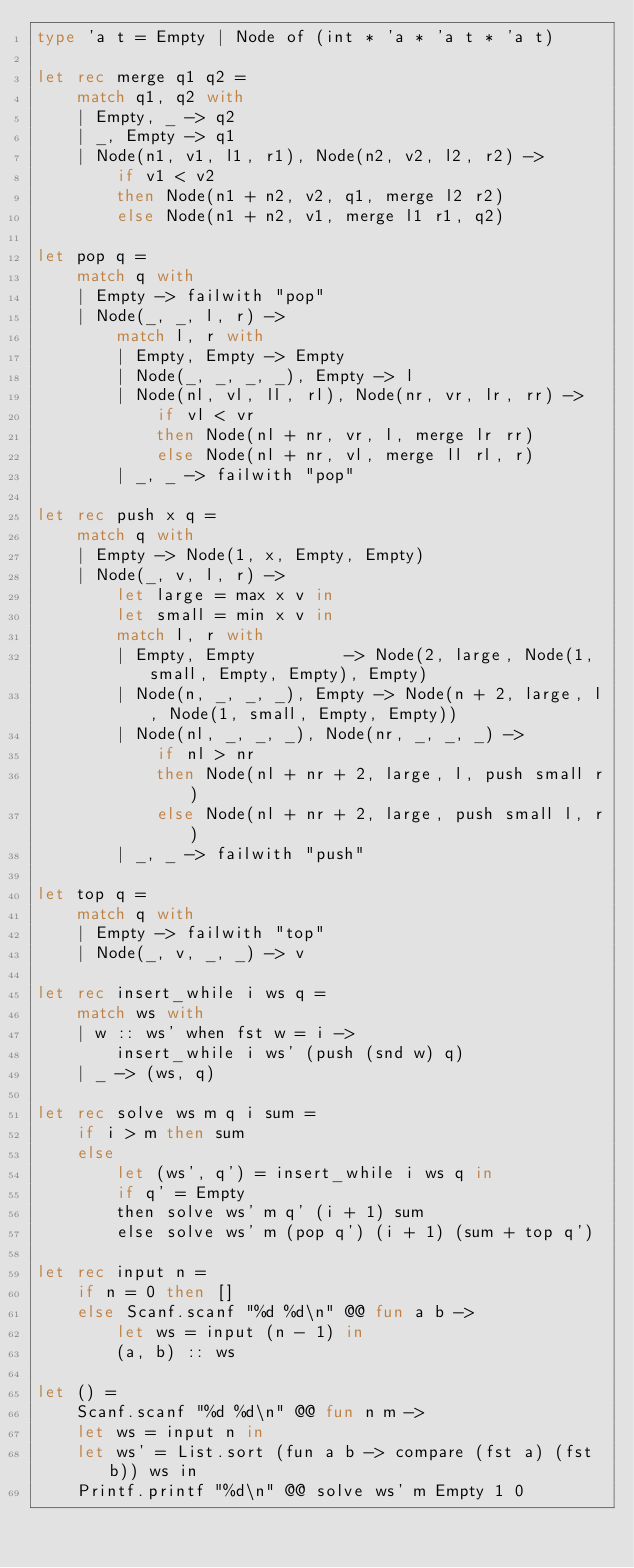<code> <loc_0><loc_0><loc_500><loc_500><_OCaml_>type 'a t = Empty | Node of (int * 'a * 'a t * 'a t)

let rec merge q1 q2 =
    match q1, q2 with
    | Empty, _ -> q2
    | _, Empty -> q1
    | Node(n1, v1, l1, r1), Node(n2, v2, l2, r2) ->
        if v1 < v2
        then Node(n1 + n2, v2, q1, merge l2 r2)
        else Node(n1 + n2, v1, merge l1 r1, q2)

let pop q =
    match q with
    | Empty -> failwith "pop"
    | Node(_, _, l, r) ->
        match l, r with
        | Empty, Empty -> Empty
        | Node(_, _, _, _), Empty -> l
        | Node(nl, vl, ll, rl), Node(nr, vr, lr, rr) ->
            if vl < vr
            then Node(nl + nr, vr, l, merge lr rr)
            else Node(nl + nr, vl, merge ll rl, r)
        | _, _ -> failwith "pop"

let rec push x q =
    match q with
    | Empty -> Node(1, x, Empty, Empty)
    | Node(_, v, l, r) ->
        let large = max x v in
        let small = min x v in
        match l, r with
        | Empty, Empty         -> Node(2, large, Node(1, small, Empty, Empty), Empty)
        | Node(n, _, _, _), Empty -> Node(n + 2, large, l, Node(1, small, Empty, Empty))
        | Node(nl, _, _, _), Node(nr, _, _, _) ->
            if nl > nr
            then Node(nl + nr + 2, large, l, push small r)
            else Node(nl + nr + 2, large, push small l, r)
        | _, _ -> failwith "push"

let top q =
    match q with
    | Empty -> failwith "top"
    | Node(_, v, _, _) -> v

let rec insert_while i ws q =
    match ws with
    | w :: ws' when fst w = i ->
        insert_while i ws' (push (snd w) q)
    | _ -> (ws, q)

let rec solve ws m q i sum =
    if i > m then sum
    else
        let (ws', q') = insert_while i ws q in
        if q' = Empty
        then solve ws' m q' (i + 1) sum
        else solve ws' m (pop q') (i + 1) (sum + top q')

let rec input n =
    if n = 0 then []
    else Scanf.scanf "%d %d\n" @@ fun a b ->
        let ws = input (n - 1) in
        (a, b) :: ws

let () =
    Scanf.scanf "%d %d\n" @@ fun n m ->
    let ws = input n in
    let ws' = List.sort (fun a b -> compare (fst a) (fst b)) ws in
    Printf.printf "%d\n" @@ solve ws' m Empty 1 0
</code> 